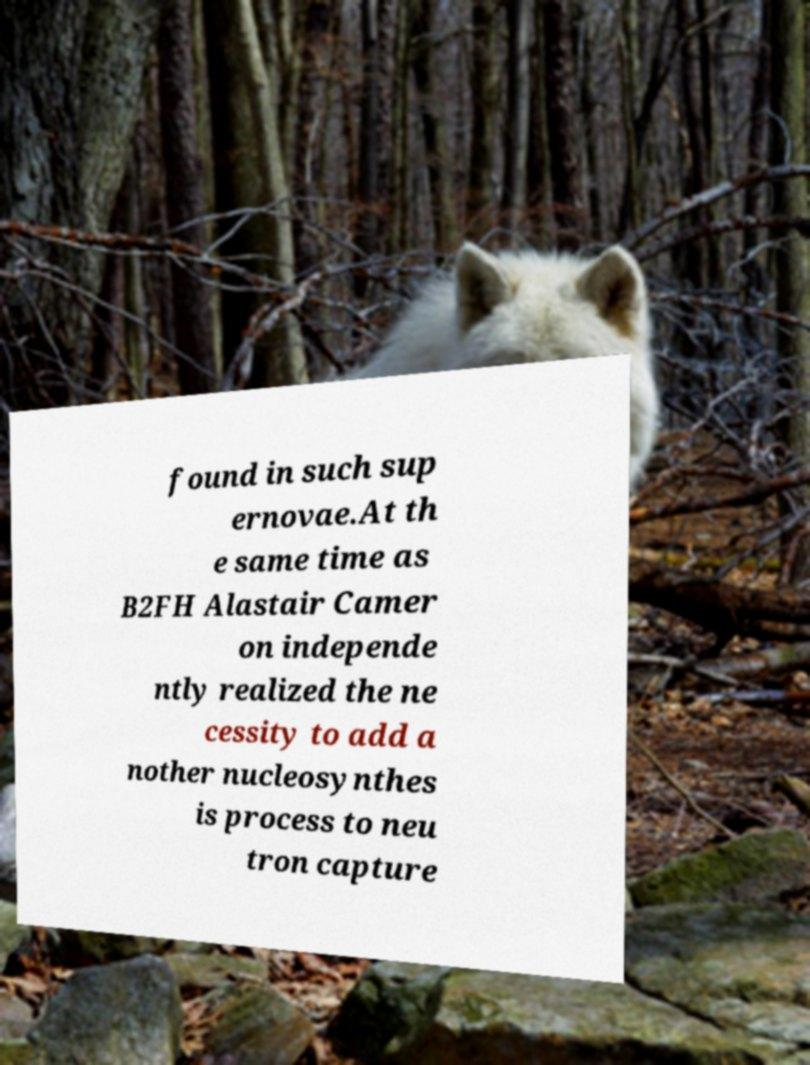There's text embedded in this image that I need extracted. Can you transcribe it verbatim? found in such sup ernovae.At th e same time as B2FH Alastair Camer on independe ntly realized the ne cessity to add a nother nucleosynthes is process to neu tron capture 